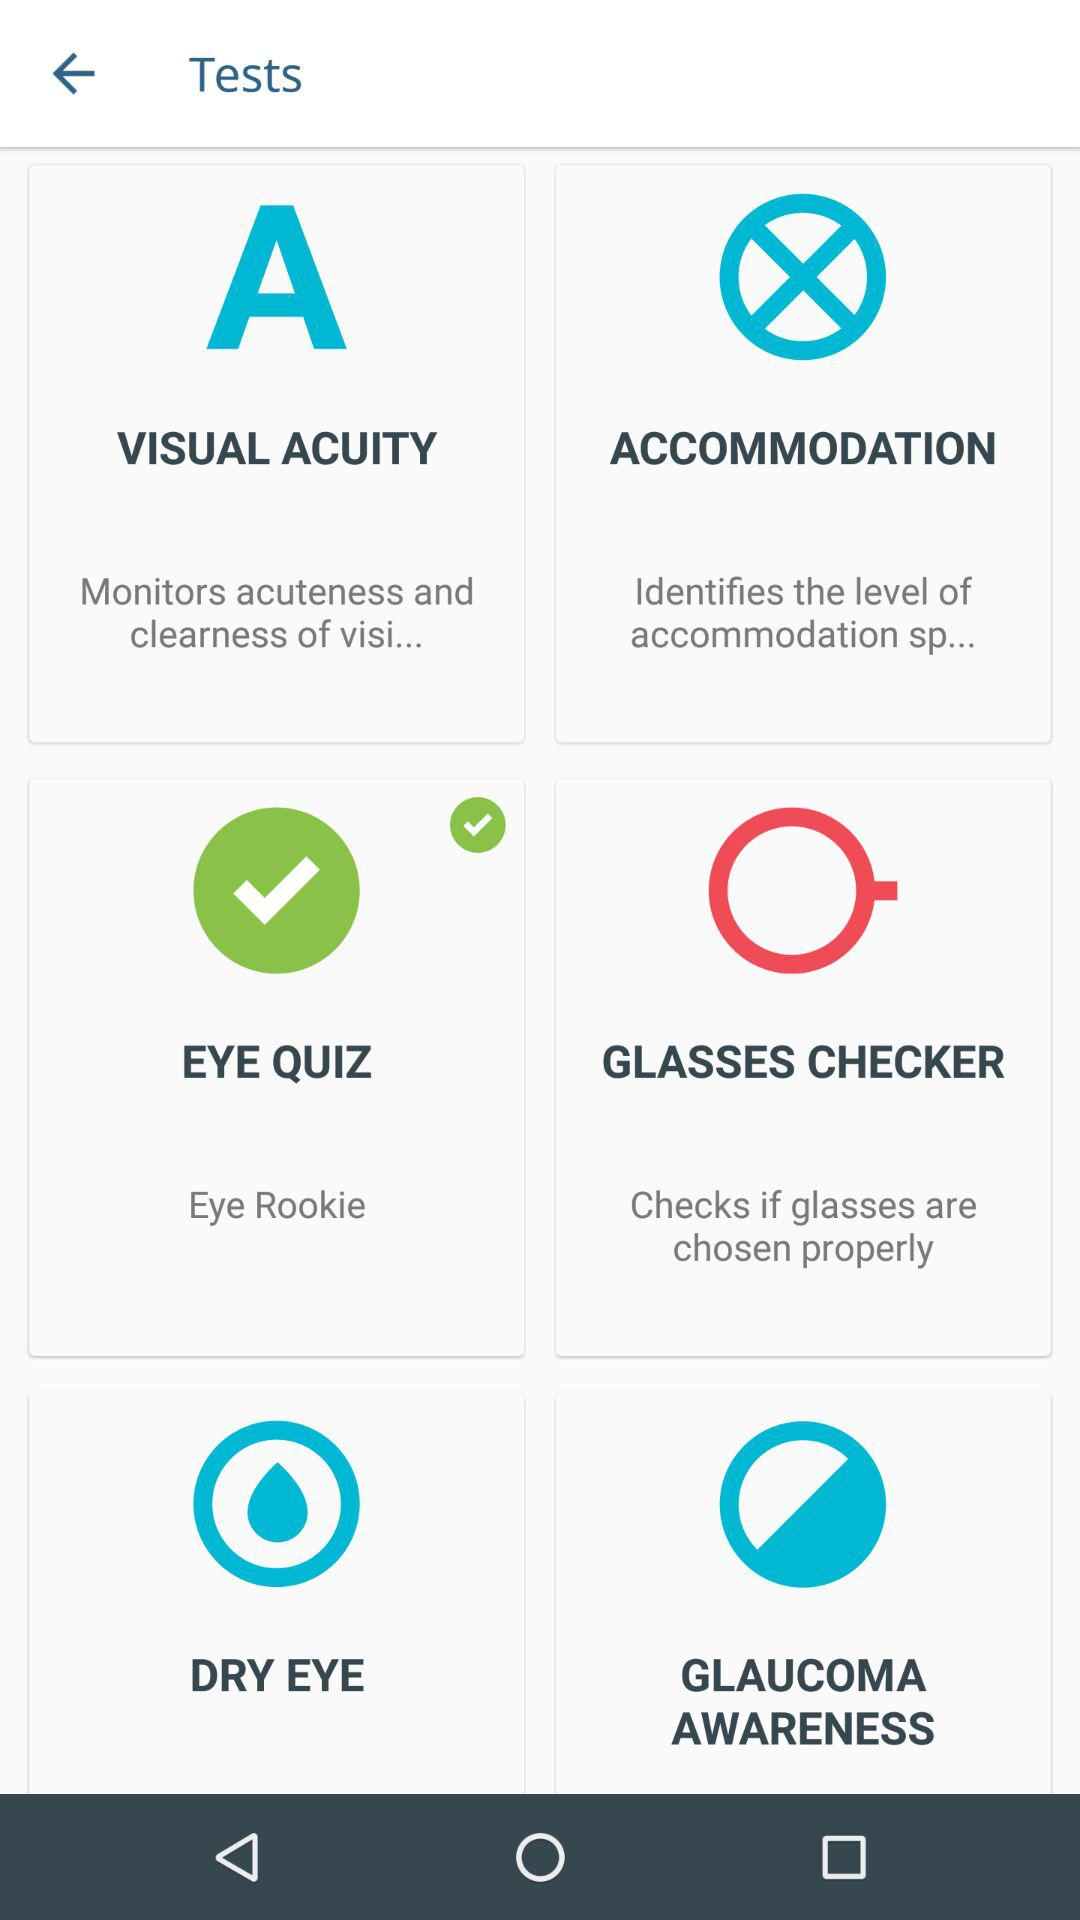What's the name of Test selected from the other Options?
When the provided information is insufficient, respond with <no answer>. <no answer> 